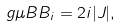Convert formula to latex. <formula><loc_0><loc_0><loc_500><loc_500>g \mu B B _ { i } = 2 i | J | ,</formula> 